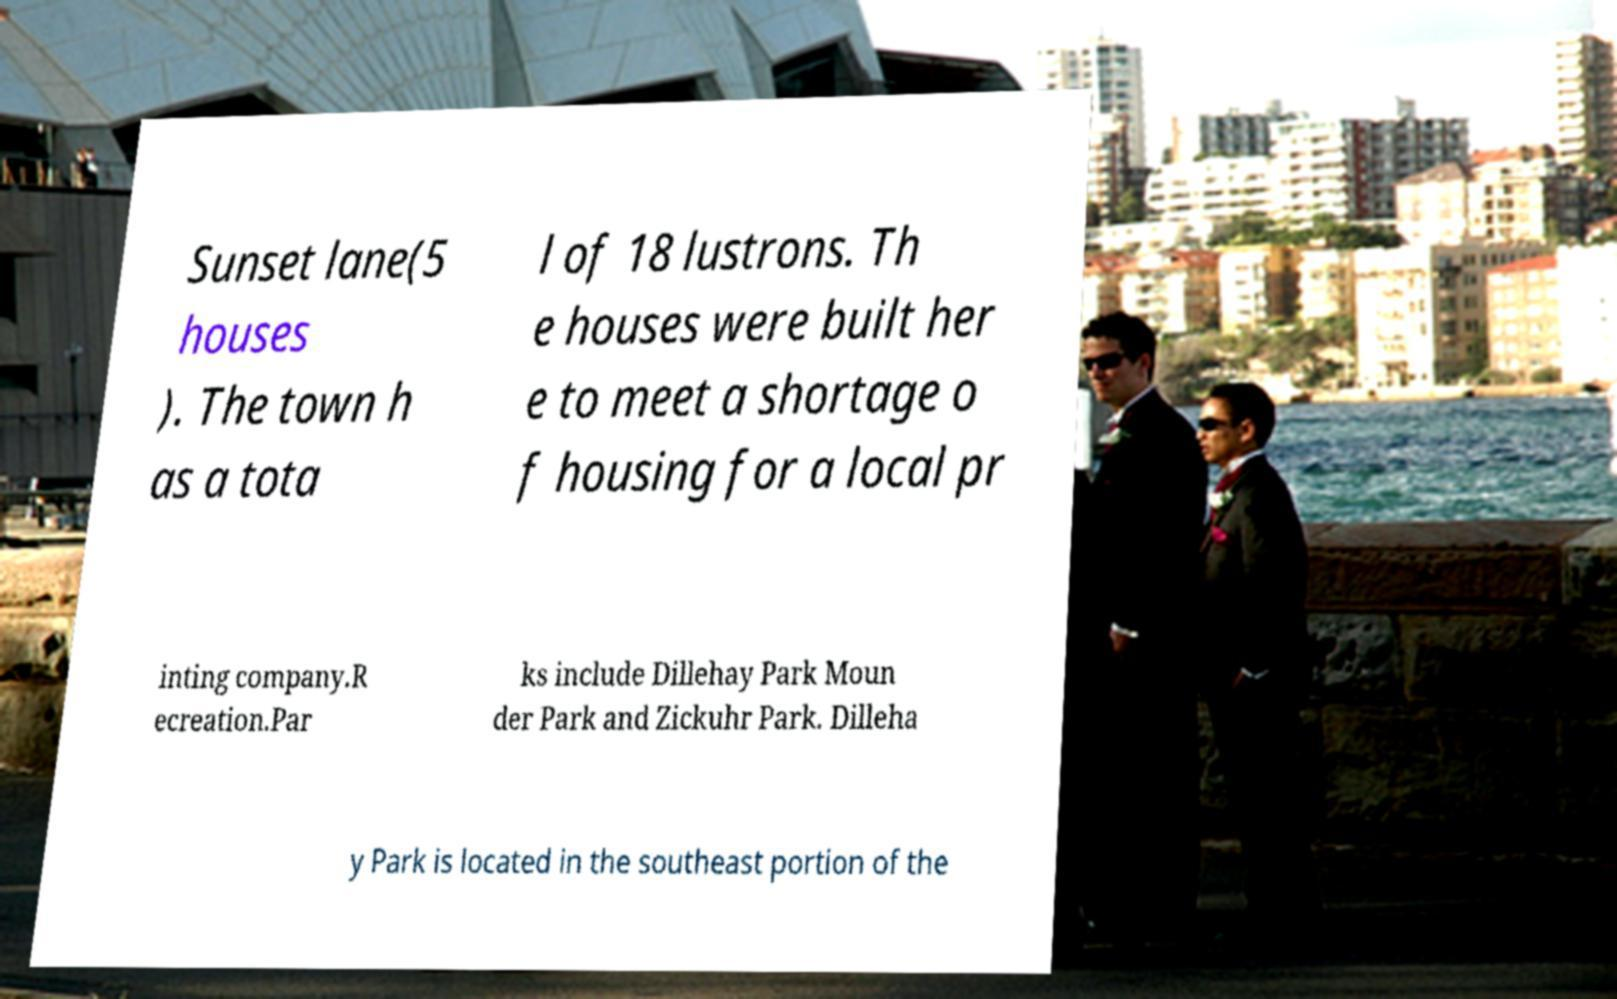Can you accurately transcribe the text from the provided image for me? Sunset lane(5 houses ). The town h as a tota l of 18 lustrons. Th e houses were built her e to meet a shortage o f housing for a local pr inting company.R ecreation.Par ks include Dillehay Park Moun der Park and Zickuhr Park. Dilleha y Park is located in the southeast portion of the 